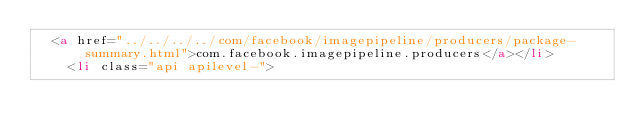<code> <loc_0><loc_0><loc_500><loc_500><_HTML_>  <a href="../../../../com/facebook/imagepipeline/producers/package-summary.html">com.facebook.imagepipeline.producers</a></li>
    <li class="api apilevel-"></code> 